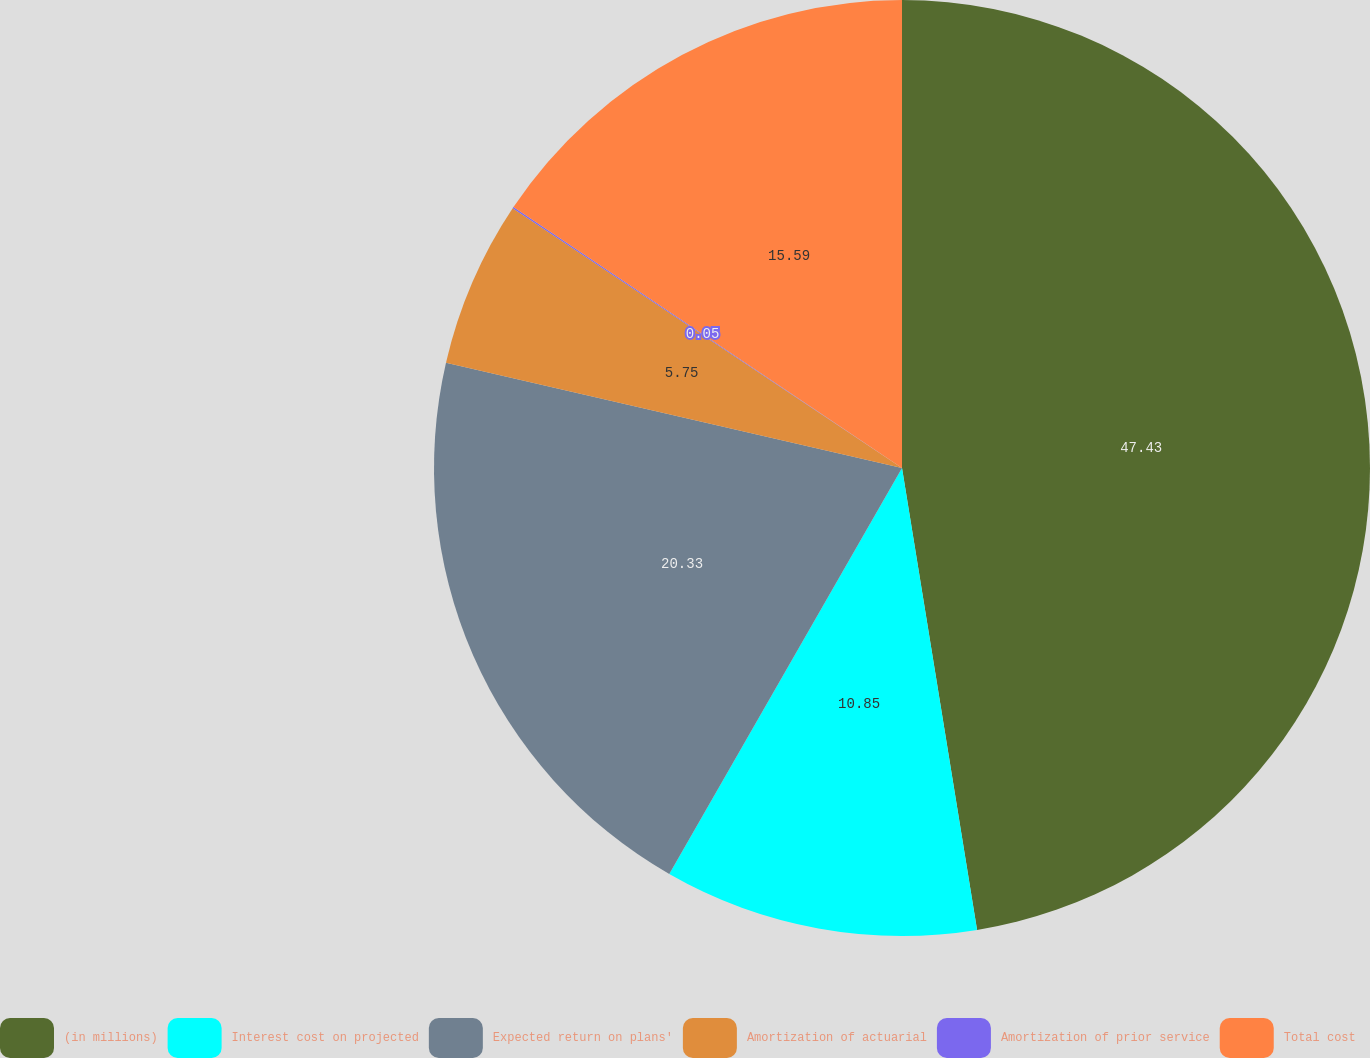Convert chart. <chart><loc_0><loc_0><loc_500><loc_500><pie_chart><fcel>(in millions)<fcel>Interest cost on projected<fcel>Expected return on plans'<fcel>Amortization of actuarial<fcel>Amortization of prior service<fcel>Total cost<nl><fcel>47.44%<fcel>10.85%<fcel>20.33%<fcel>5.75%<fcel>0.05%<fcel>15.59%<nl></chart> 